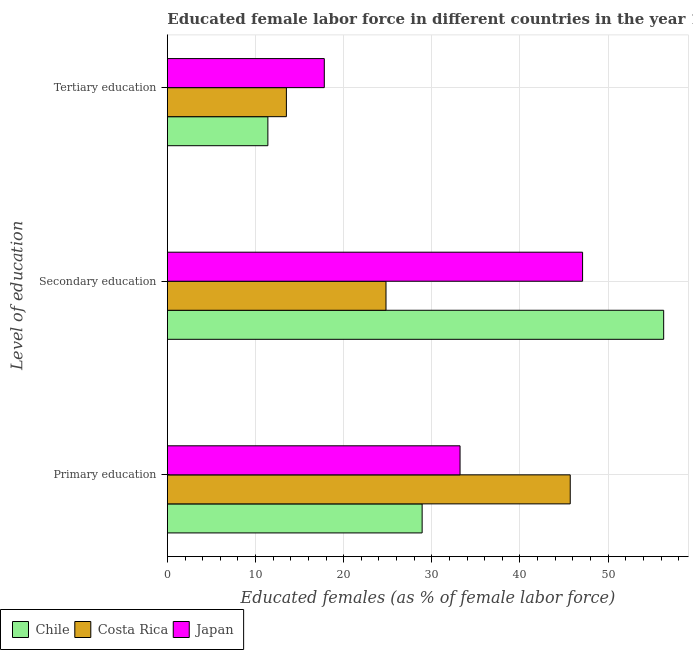Are the number of bars per tick equal to the number of legend labels?
Your response must be concise. Yes. Are the number of bars on each tick of the Y-axis equal?
Your answer should be compact. Yes. What is the label of the 2nd group of bars from the top?
Offer a very short reply. Secondary education. What is the percentage of female labor force who received secondary education in Costa Rica?
Your answer should be compact. 24.8. Across all countries, what is the maximum percentage of female labor force who received tertiary education?
Ensure brevity in your answer.  17.8. Across all countries, what is the minimum percentage of female labor force who received tertiary education?
Provide a short and direct response. 11.4. In which country was the percentage of female labor force who received primary education maximum?
Offer a very short reply. Costa Rica. What is the total percentage of female labor force who received secondary education in the graph?
Offer a terse response. 128.2. What is the difference between the percentage of female labor force who received primary education in Chile and that in Costa Rica?
Keep it short and to the point. -16.8. What is the difference between the percentage of female labor force who received secondary education in Costa Rica and the percentage of female labor force who received tertiary education in Chile?
Keep it short and to the point. 13.4. What is the average percentage of female labor force who received secondary education per country?
Offer a terse response. 42.73. What is the difference between the percentage of female labor force who received secondary education and percentage of female labor force who received tertiary education in Costa Rica?
Offer a very short reply. 11.3. What is the ratio of the percentage of female labor force who received primary education in Japan to that in Costa Rica?
Ensure brevity in your answer.  0.73. Is the difference between the percentage of female labor force who received tertiary education in Japan and Chile greater than the difference between the percentage of female labor force who received secondary education in Japan and Chile?
Your response must be concise. Yes. What is the difference between the highest and the second highest percentage of female labor force who received secondary education?
Make the answer very short. 9.2. What is the difference between the highest and the lowest percentage of female labor force who received tertiary education?
Offer a very short reply. 6.4. In how many countries, is the percentage of female labor force who received tertiary education greater than the average percentage of female labor force who received tertiary education taken over all countries?
Provide a succinct answer. 1. What does the 1st bar from the bottom in Tertiary education represents?
Offer a terse response. Chile. Are all the bars in the graph horizontal?
Provide a short and direct response. Yes. How many countries are there in the graph?
Offer a terse response. 3. What is the difference between two consecutive major ticks on the X-axis?
Make the answer very short. 10. Are the values on the major ticks of X-axis written in scientific E-notation?
Your response must be concise. No. Does the graph contain any zero values?
Keep it short and to the point. No. Does the graph contain grids?
Keep it short and to the point. Yes. What is the title of the graph?
Provide a succinct answer. Educated female labor force in different countries in the year 1990. What is the label or title of the X-axis?
Your response must be concise. Educated females (as % of female labor force). What is the label or title of the Y-axis?
Provide a succinct answer. Level of education. What is the Educated females (as % of female labor force) in Chile in Primary education?
Your answer should be compact. 28.9. What is the Educated females (as % of female labor force) in Costa Rica in Primary education?
Give a very brief answer. 45.7. What is the Educated females (as % of female labor force) of Japan in Primary education?
Give a very brief answer. 33.2. What is the Educated females (as % of female labor force) of Chile in Secondary education?
Offer a terse response. 56.3. What is the Educated females (as % of female labor force) of Costa Rica in Secondary education?
Give a very brief answer. 24.8. What is the Educated females (as % of female labor force) in Japan in Secondary education?
Keep it short and to the point. 47.1. What is the Educated females (as % of female labor force) in Chile in Tertiary education?
Keep it short and to the point. 11.4. What is the Educated females (as % of female labor force) in Costa Rica in Tertiary education?
Offer a very short reply. 13.5. What is the Educated females (as % of female labor force) in Japan in Tertiary education?
Ensure brevity in your answer.  17.8. Across all Level of education, what is the maximum Educated females (as % of female labor force) of Chile?
Keep it short and to the point. 56.3. Across all Level of education, what is the maximum Educated females (as % of female labor force) of Costa Rica?
Make the answer very short. 45.7. Across all Level of education, what is the maximum Educated females (as % of female labor force) in Japan?
Provide a short and direct response. 47.1. Across all Level of education, what is the minimum Educated females (as % of female labor force) in Chile?
Ensure brevity in your answer.  11.4. Across all Level of education, what is the minimum Educated females (as % of female labor force) in Japan?
Offer a very short reply. 17.8. What is the total Educated females (as % of female labor force) of Chile in the graph?
Give a very brief answer. 96.6. What is the total Educated females (as % of female labor force) in Japan in the graph?
Your answer should be compact. 98.1. What is the difference between the Educated females (as % of female labor force) in Chile in Primary education and that in Secondary education?
Your answer should be compact. -27.4. What is the difference between the Educated females (as % of female labor force) of Costa Rica in Primary education and that in Secondary education?
Make the answer very short. 20.9. What is the difference between the Educated females (as % of female labor force) in Japan in Primary education and that in Secondary education?
Your answer should be very brief. -13.9. What is the difference between the Educated females (as % of female labor force) of Costa Rica in Primary education and that in Tertiary education?
Give a very brief answer. 32.2. What is the difference between the Educated females (as % of female labor force) in Japan in Primary education and that in Tertiary education?
Provide a succinct answer. 15.4. What is the difference between the Educated females (as % of female labor force) in Chile in Secondary education and that in Tertiary education?
Keep it short and to the point. 44.9. What is the difference between the Educated females (as % of female labor force) of Costa Rica in Secondary education and that in Tertiary education?
Ensure brevity in your answer.  11.3. What is the difference between the Educated females (as % of female labor force) of Japan in Secondary education and that in Tertiary education?
Make the answer very short. 29.3. What is the difference between the Educated females (as % of female labor force) in Chile in Primary education and the Educated females (as % of female labor force) in Costa Rica in Secondary education?
Your answer should be compact. 4.1. What is the difference between the Educated females (as % of female labor force) in Chile in Primary education and the Educated females (as % of female labor force) in Japan in Secondary education?
Provide a short and direct response. -18.2. What is the difference between the Educated females (as % of female labor force) in Costa Rica in Primary education and the Educated females (as % of female labor force) in Japan in Secondary education?
Give a very brief answer. -1.4. What is the difference between the Educated females (as % of female labor force) of Chile in Primary education and the Educated females (as % of female labor force) of Costa Rica in Tertiary education?
Give a very brief answer. 15.4. What is the difference between the Educated females (as % of female labor force) of Chile in Primary education and the Educated females (as % of female labor force) of Japan in Tertiary education?
Provide a succinct answer. 11.1. What is the difference between the Educated females (as % of female labor force) of Costa Rica in Primary education and the Educated females (as % of female labor force) of Japan in Tertiary education?
Offer a very short reply. 27.9. What is the difference between the Educated females (as % of female labor force) of Chile in Secondary education and the Educated females (as % of female labor force) of Costa Rica in Tertiary education?
Your response must be concise. 42.8. What is the difference between the Educated females (as % of female labor force) of Chile in Secondary education and the Educated females (as % of female labor force) of Japan in Tertiary education?
Keep it short and to the point. 38.5. What is the average Educated females (as % of female labor force) in Chile per Level of education?
Your answer should be compact. 32.2. What is the average Educated females (as % of female labor force) of Japan per Level of education?
Your answer should be very brief. 32.7. What is the difference between the Educated females (as % of female labor force) of Chile and Educated females (as % of female labor force) of Costa Rica in Primary education?
Offer a very short reply. -16.8. What is the difference between the Educated females (as % of female labor force) in Chile and Educated females (as % of female labor force) in Japan in Primary education?
Offer a terse response. -4.3. What is the difference between the Educated females (as % of female labor force) of Costa Rica and Educated females (as % of female labor force) of Japan in Primary education?
Your answer should be compact. 12.5. What is the difference between the Educated females (as % of female labor force) of Chile and Educated females (as % of female labor force) of Costa Rica in Secondary education?
Your answer should be very brief. 31.5. What is the difference between the Educated females (as % of female labor force) of Costa Rica and Educated females (as % of female labor force) of Japan in Secondary education?
Your answer should be very brief. -22.3. What is the difference between the Educated females (as % of female labor force) in Chile and Educated females (as % of female labor force) in Costa Rica in Tertiary education?
Provide a short and direct response. -2.1. What is the difference between the Educated females (as % of female labor force) in Costa Rica and Educated females (as % of female labor force) in Japan in Tertiary education?
Make the answer very short. -4.3. What is the ratio of the Educated females (as % of female labor force) in Chile in Primary education to that in Secondary education?
Offer a terse response. 0.51. What is the ratio of the Educated females (as % of female labor force) of Costa Rica in Primary education to that in Secondary education?
Offer a terse response. 1.84. What is the ratio of the Educated females (as % of female labor force) of Japan in Primary education to that in Secondary education?
Your answer should be compact. 0.7. What is the ratio of the Educated females (as % of female labor force) in Chile in Primary education to that in Tertiary education?
Provide a short and direct response. 2.54. What is the ratio of the Educated females (as % of female labor force) of Costa Rica in Primary education to that in Tertiary education?
Your response must be concise. 3.39. What is the ratio of the Educated females (as % of female labor force) of Japan in Primary education to that in Tertiary education?
Your answer should be very brief. 1.87. What is the ratio of the Educated females (as % of female labor force) of Chile in Secondary education to that in Tertiary education?
Your response must be concise. 4.94. What is the ratio of the Educated females (as % of female labor force) in Costa Rica in Secondary education to that in Tertiary education?
Your answer should be very brief. 1.84. What is the ratio of the Educated females (as % of female labor force) of Japan in Secondary education to that in Tertiary education?
Your answer should be compact. 2.65. What is the difference between the highest and the second highest Educated females (as % of female labor force) in Chile?
Keep it short and to the point. 27.4. What is the difference between the highest and the second highest Educated females (as % of female labor force) in Costa Rica?
Ensure brevity in your answer.  20.9. What is the difference between the highest and the lowest Educated females (as % of female labor force) of Chile?
Give a very brief answer. 44.9. What is the difference between the highest and the lowest Educated females (as % of female labor force) in Costa Rica?
Your response must be concise. 32.2. What is the difference between the highest and the lowest Educated females (as % of female labor force) in Japan?
Give a very brief answer. 29.3. 